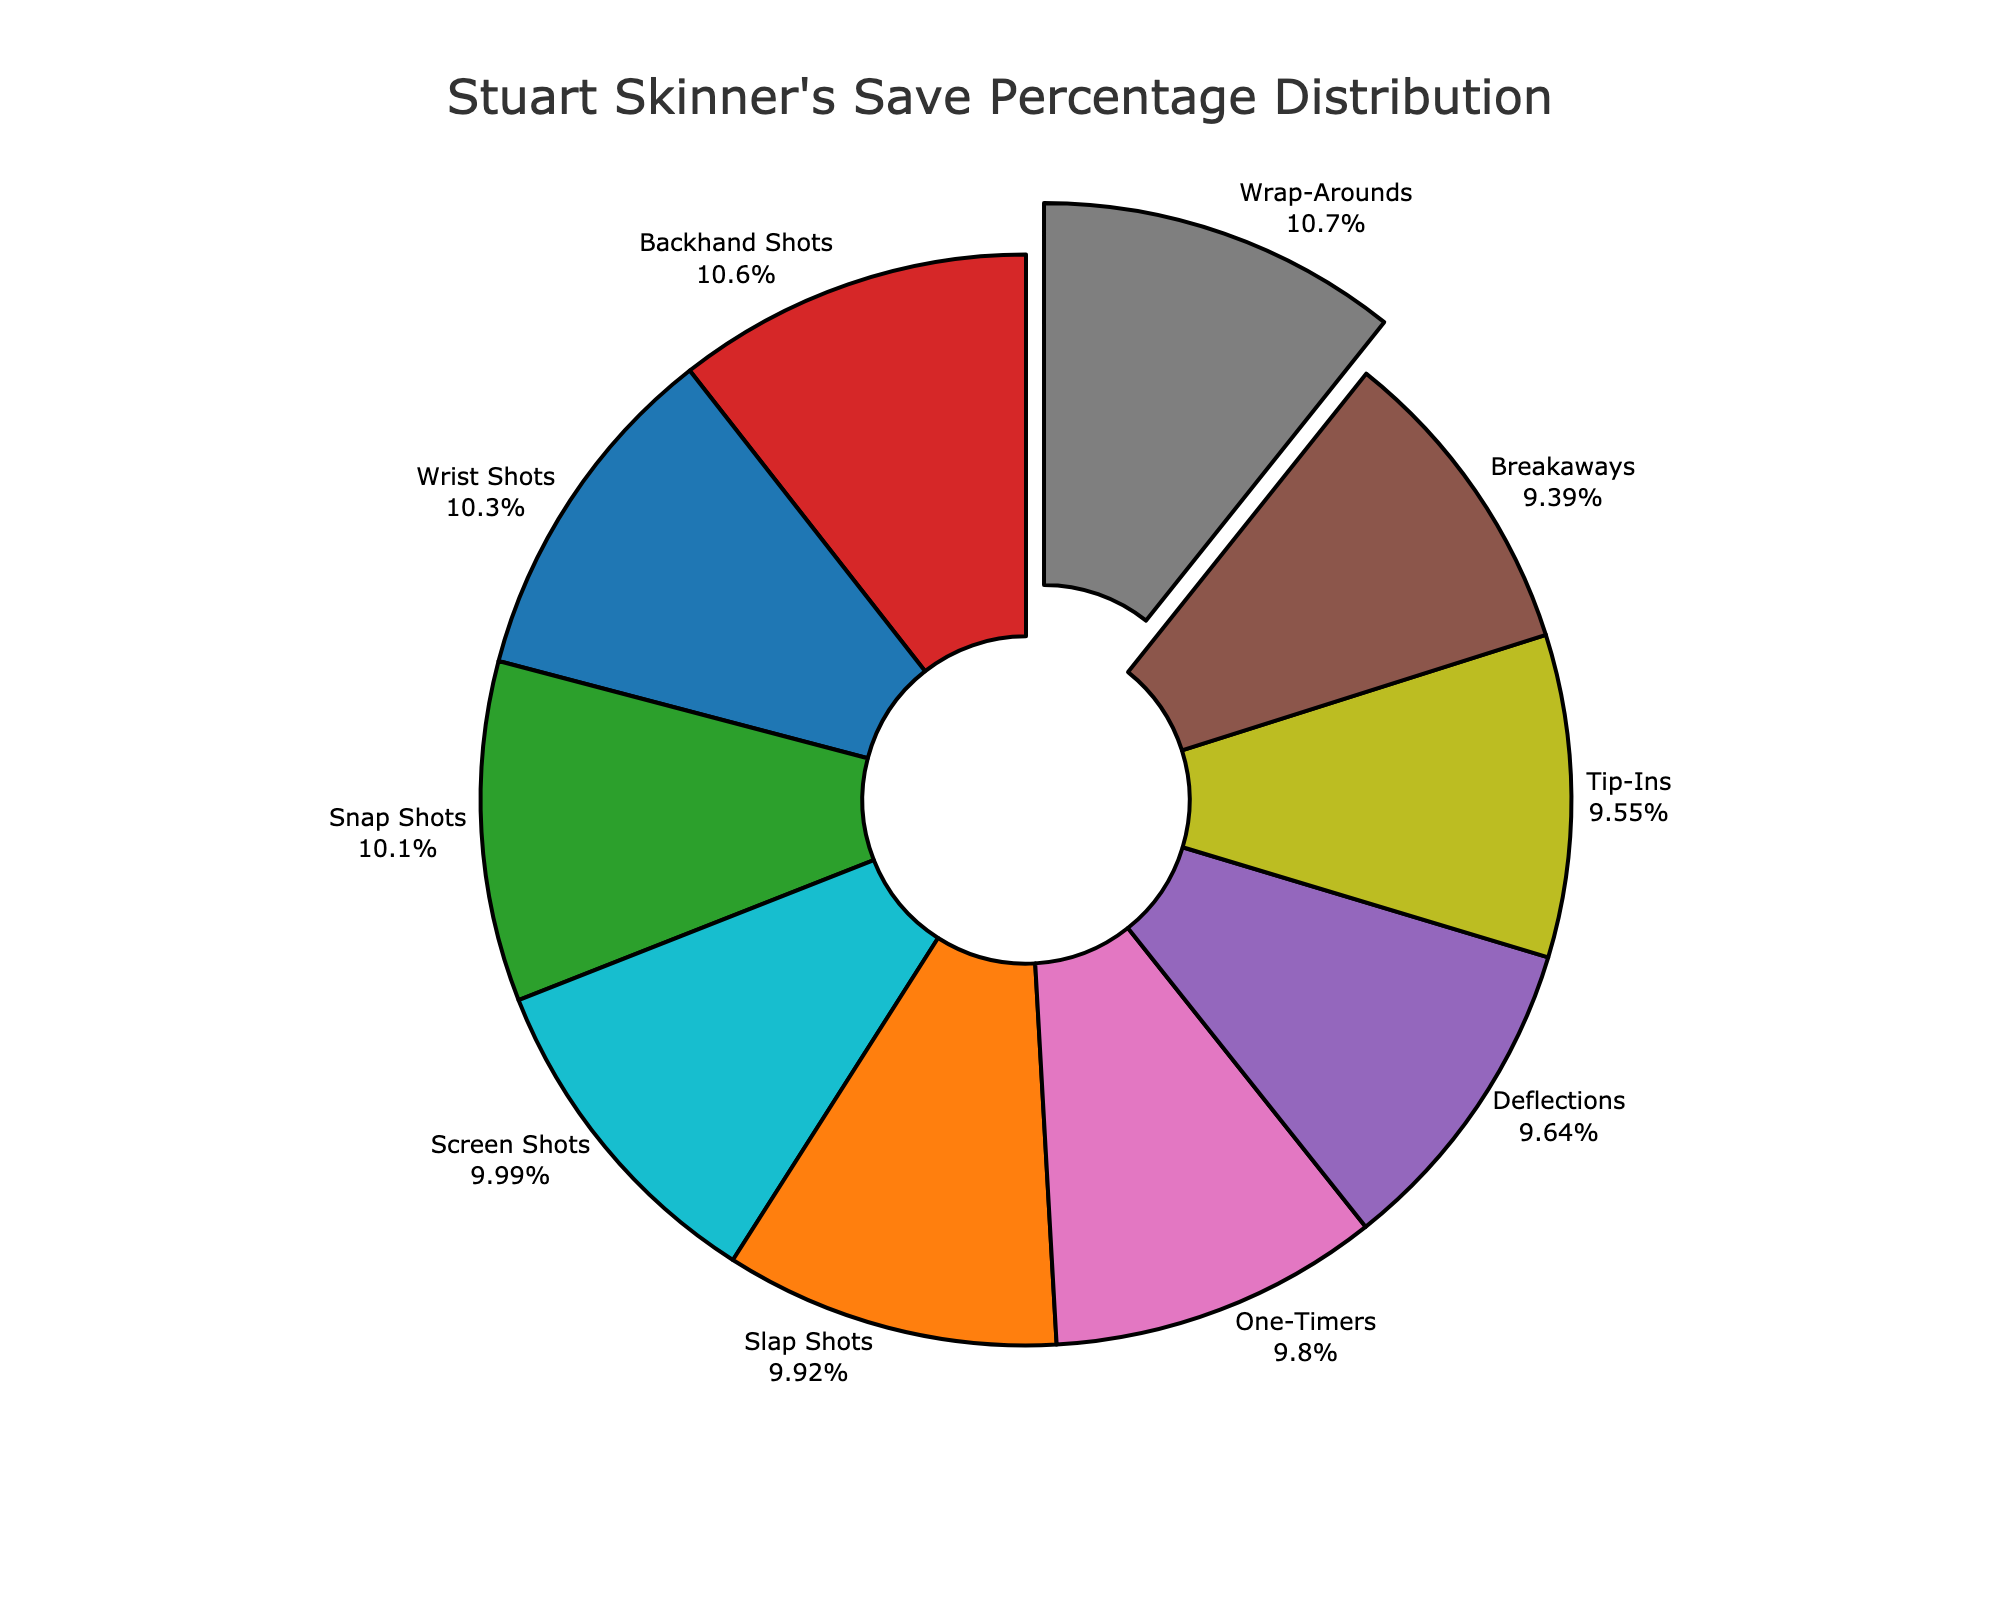What shot type has Stuart Skinner's highest save percentage? The figure visually highlights the shot type with the highest save percentage by pulling that segment out from the pie chart.
Answer: Wrap-Arounds What shot type has Stuart Skinner's lowest save percentage? By examining the pie chart segments and their corresponding percentages, the lowest save percentage can be identified.
Answer: Breakaways What is the difference between the save percentage for Deflections and One-Timers? Identify the save percentages for Deflections (86.2%) and One-Timers (87.6%) from the chart, then calculate the difference: 87.6% - 86.2%.
Answer: 1.4% What is the average save percentage for Wrist Shots, Snap Shots, and Screen Shots? Find the individual save percentages: Wrist Shots (92.3%), Snap Shots (90.1%), and Screen Shots (89.3%). Calculate the average: (92.3 + 90.1 + 89.3) / 3.
Answer: 90.57% Which shot types have a save percentage greater than 90%? Identify shot types with a save percentage exceeding 90% by observing the pie chart's segments.
Answer: Wrist Shots, Snap Shots, Backhand Shots, Wrap-Arounds Are the total save percentages for Slap Shots and Tip-Ins greater than those for Deflections and Breakaways combined? Compare the combined save percentages. Slap Shots (88.7%) + Tip-Ins (85.4%) = 174.1%; Deflections (86.2%) + Breakaways (83.9%) = 170.1%.
Answer: Yes Which two shot types with closest save percentages? Look for the closest numerical values in the pie chart sections and identify the shot types.
Answer: Deflections and One-Timers Is the save percentage for Backhand Shots higher or lower than the median save percentage of all shot types? Find the median by listing all save percentages in numerical order, determine the middle value, and compare it with Backhand Shots (94.5%).
Answer: Higher Which segment is represented by the color blue, and what is its save percentage? Identify the segment colored blue in the pie chart and its corresponding save percentage.
Answer: Wrist Shots, 92.3% What is the combined save percentage for Snap Shots, Backhand Shots, and Wrap-Arounds? Add the percentages for Snap Shots (90.1%), Backhand Shots (94.5%), and Wrap-Arounds (95.8%): 90.1% + 94.5% + 95.8%.
Answer: 280.4% 